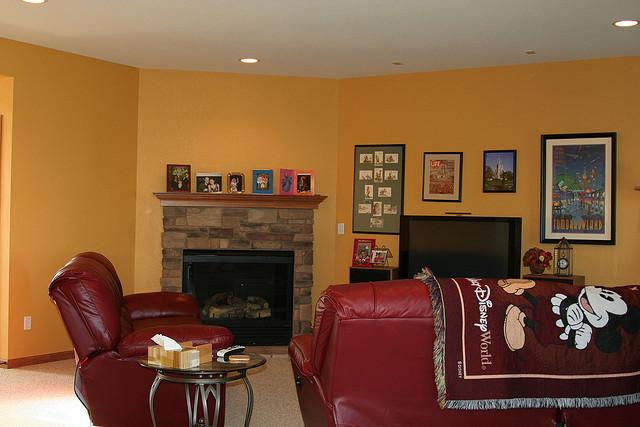What does the blanket say?
Be succinct. Walt disney world. What color are the walls?
Quick response, please. Yellow. What color is the wall?
Give a very brief answer. Yellow. What color is the sofa?
Write a very short answer. Red. What color are the couches?
Short answer required. Red. 